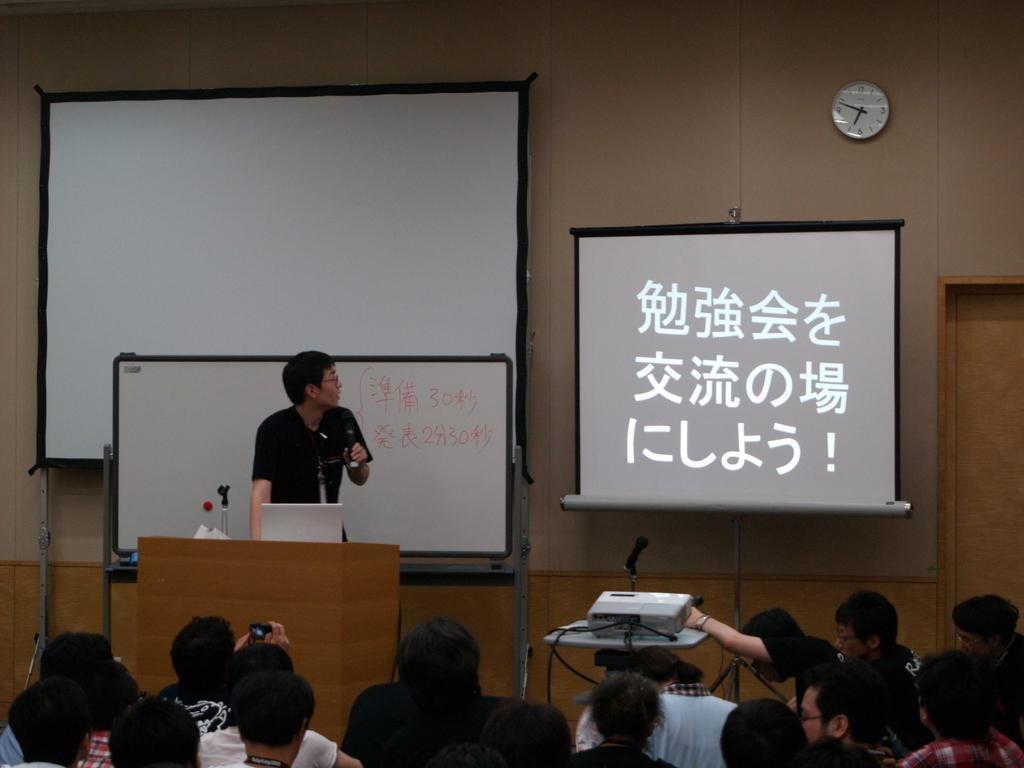Please provide a concise description of this image. Here in this picture in the front we can see number of people sitting on chairs present over there and in front of them we can see a person standing on the stage with a speech desk present in front of him, having a laptop and microphone on it and beside him we can see a table, on which we can see a projector and a microphone present and in front of that we can see a projector screen with something projected on it and behind the person we can see a white board present and behind it we can see another projector screen present and we can see a clock on the wall. 